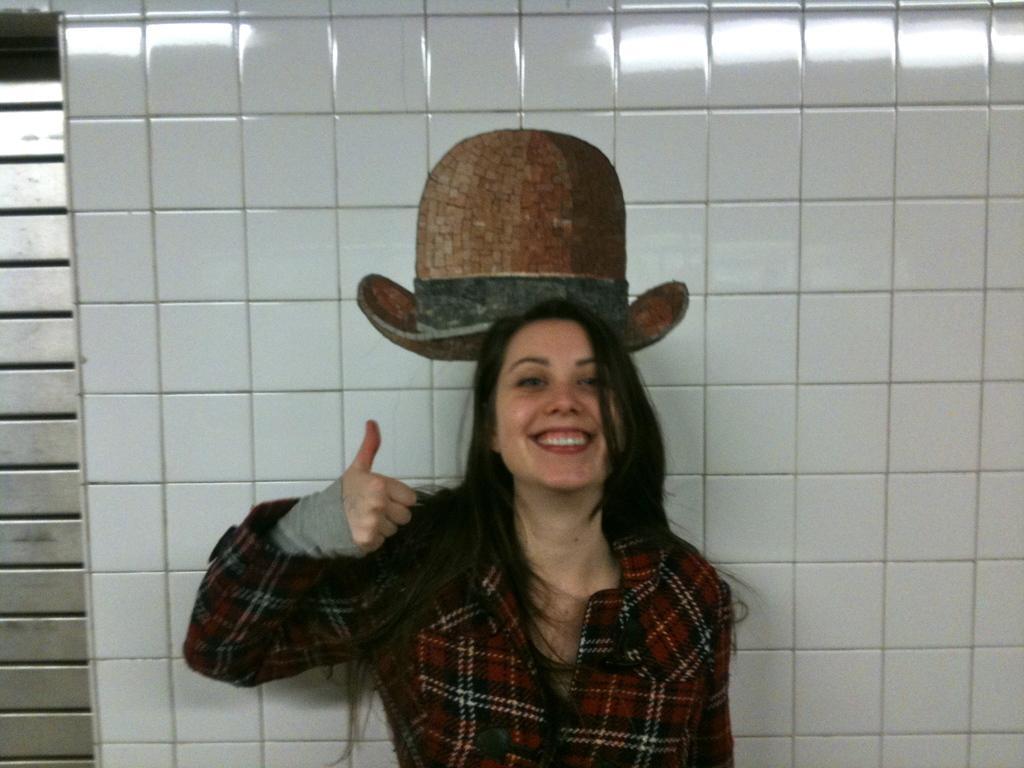How would you summarize this image in a sentence or two? In the center of the image we can see one person is standing and she is smiling, which we can see on her face. In the background there is a wall and a few other objects. And we can see the painting of a hat on the wall. 